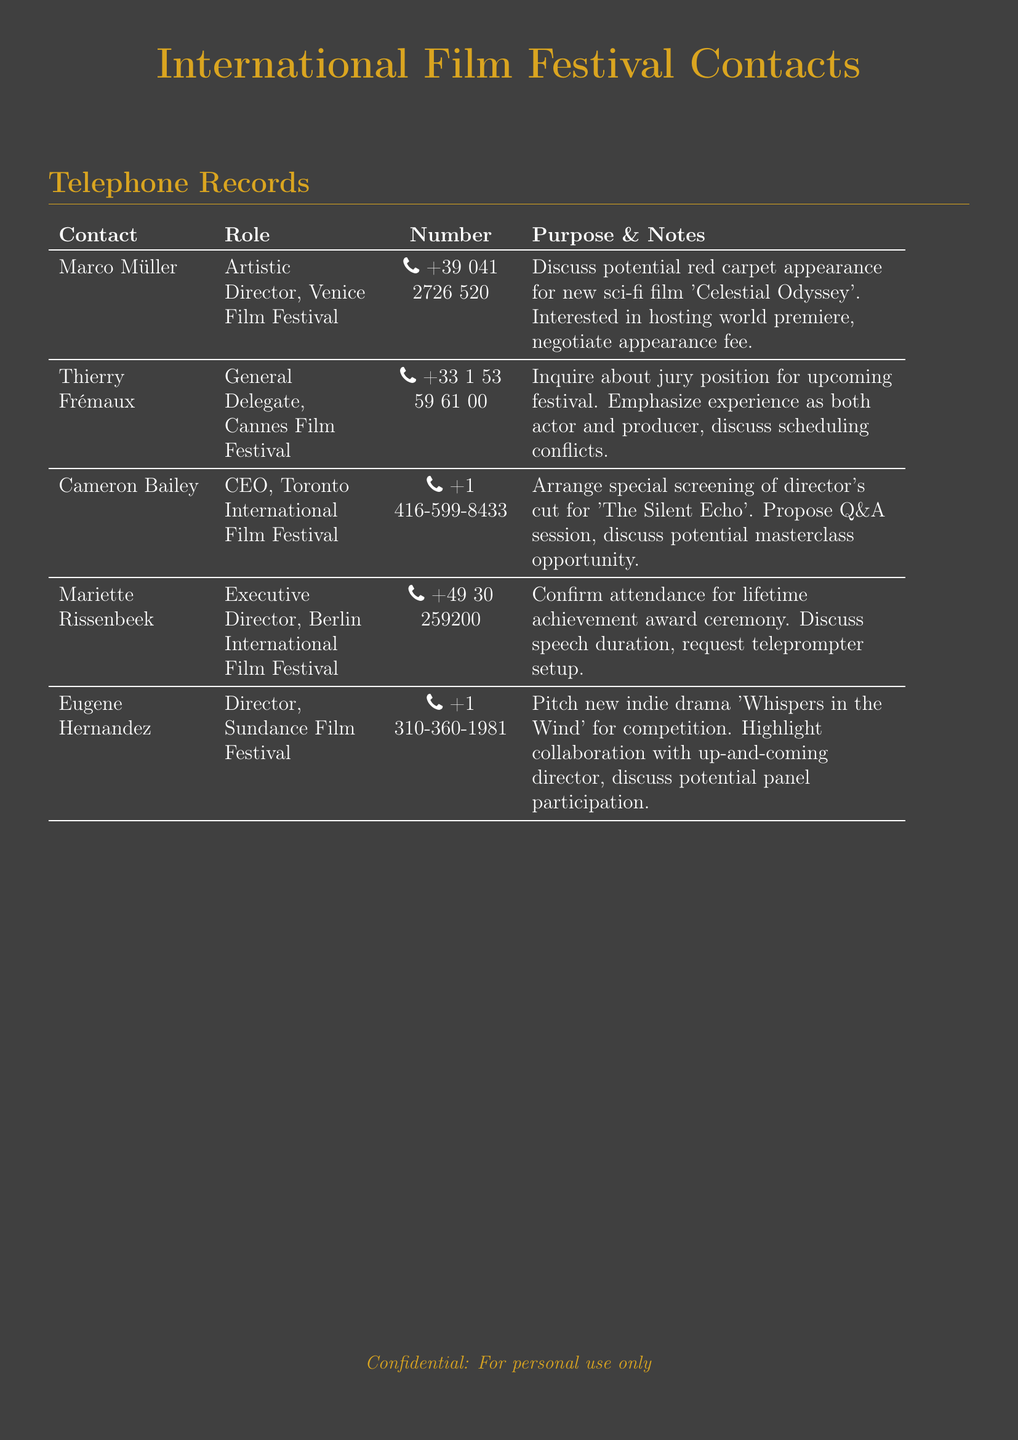What is the phone number for Marco Müller? The phone number for Marco Müller can be found under his contact details, which is +39 041 2726 520.
Answer: +39 041 2726 520 Who is the Executive Director of the Berlin International Film Festival? The Executive Director of the Berlin International Film Festival is Mariette Rissenbeek, as listed in the document.
Answer: Mariette Rissenbeek What film was pitched to the Sundance Film Festival? The indie drama 'Whispers in the Wind' is pitched to the Sundance Film Festival according to the document.
Answer: Whispers in the Wind Which festival is associated with Thierry Frémaux? Thierry Frémaux is associated with the Cannes Film Festival, as mentioned in the contact details.
Answer: Cannes Film Festival What is the purpose of the call to Cameron Bailey? The purpose of the call to Cameron Bailey includes arranging a special screening of 'The Silent Echo' as stated in the document.
Answer: Arrange special screening How many contacts are listed in the telephone records? The document lists a total of five contacts for international film festival organizers.
Answer: Five What role does Eugene Hernandez hold? Eugene Hernandez holds the role of Director at the Sundance Film Festival, which is specified in the document.
Answer: Director What event is Mariette Rissenbeek confirming attendance for? Mariette Rissenbeek is confirming attendance for a lifetime achievement award ceremony mentioned in the notes.
Answer: Lifetime achievement award ceremony What does Marco Müller want to negotiate? Marco Müller wants to negotiate an appearance fee, as indicated in the purpose and notes section.
Answer: Appearance fee 